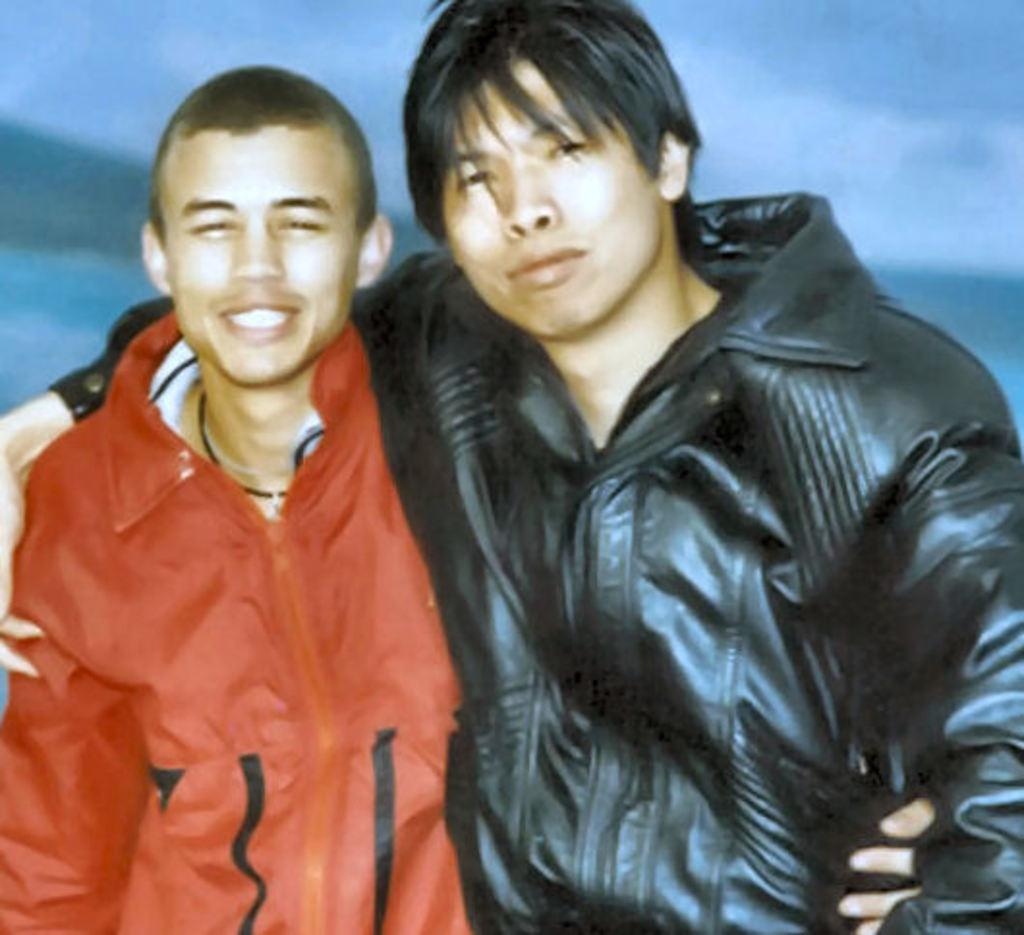How many people are in the image? There are two people in the image. What are the people doing in the image? Both people are standing in the image. What expression do the people have in the image? The people are smiling in the image. What advice is the person on the left giving to the person on the right in the image? There is no indication in the image that the people are giving or receiving advice. 